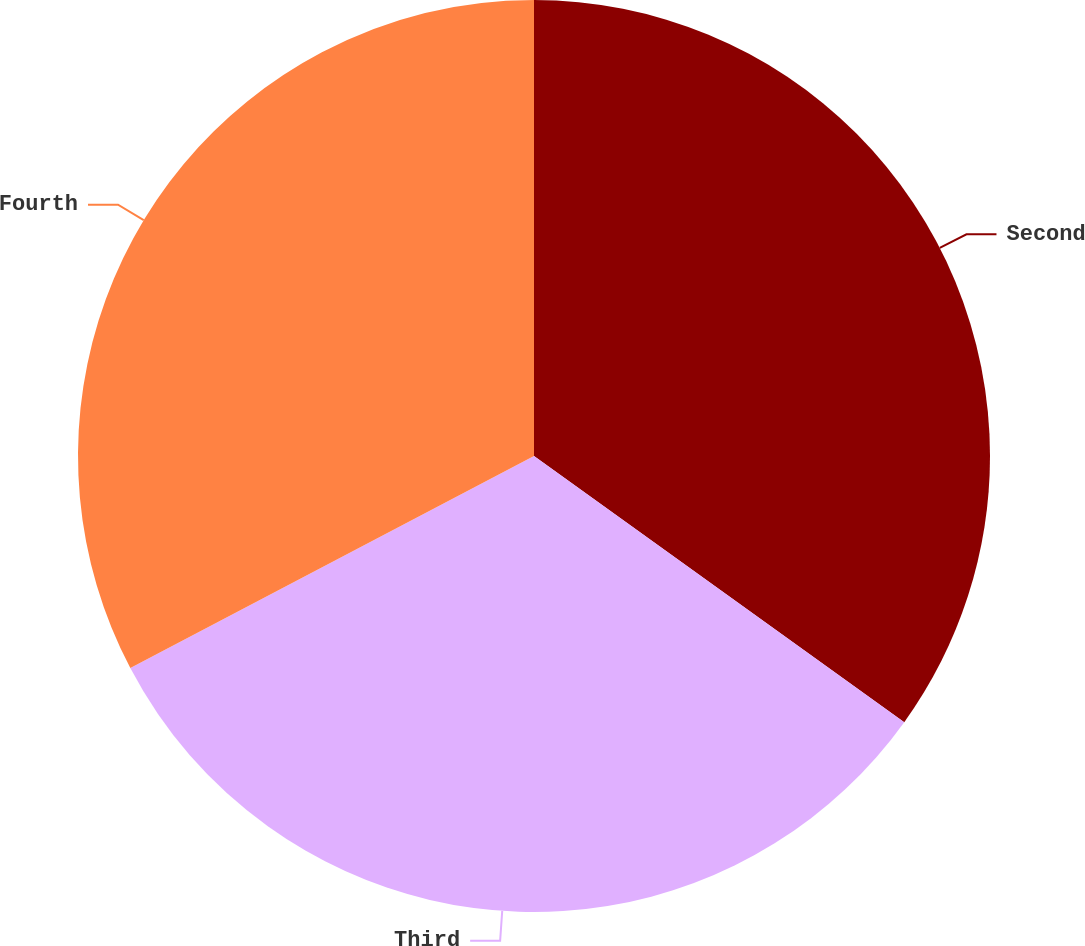<chart> <loc_0><loc_0><loc_500><loc_500><pie_chart><fcel>Second<fcel>Third<fcel>Fourth<nl><fcel>34.92%<fcel>32.38%<fcel>32.7%<nl></chart> 